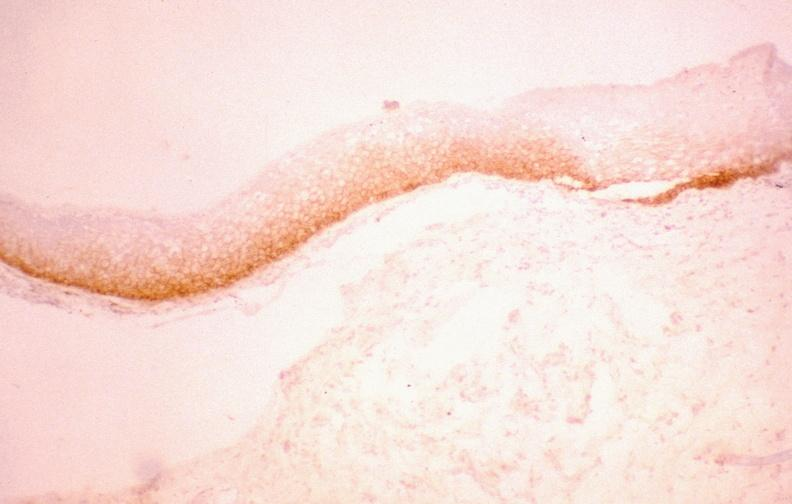does this image show oral dysplasia, egf receptor?
Answer the question using a single word or phrase. Yes 